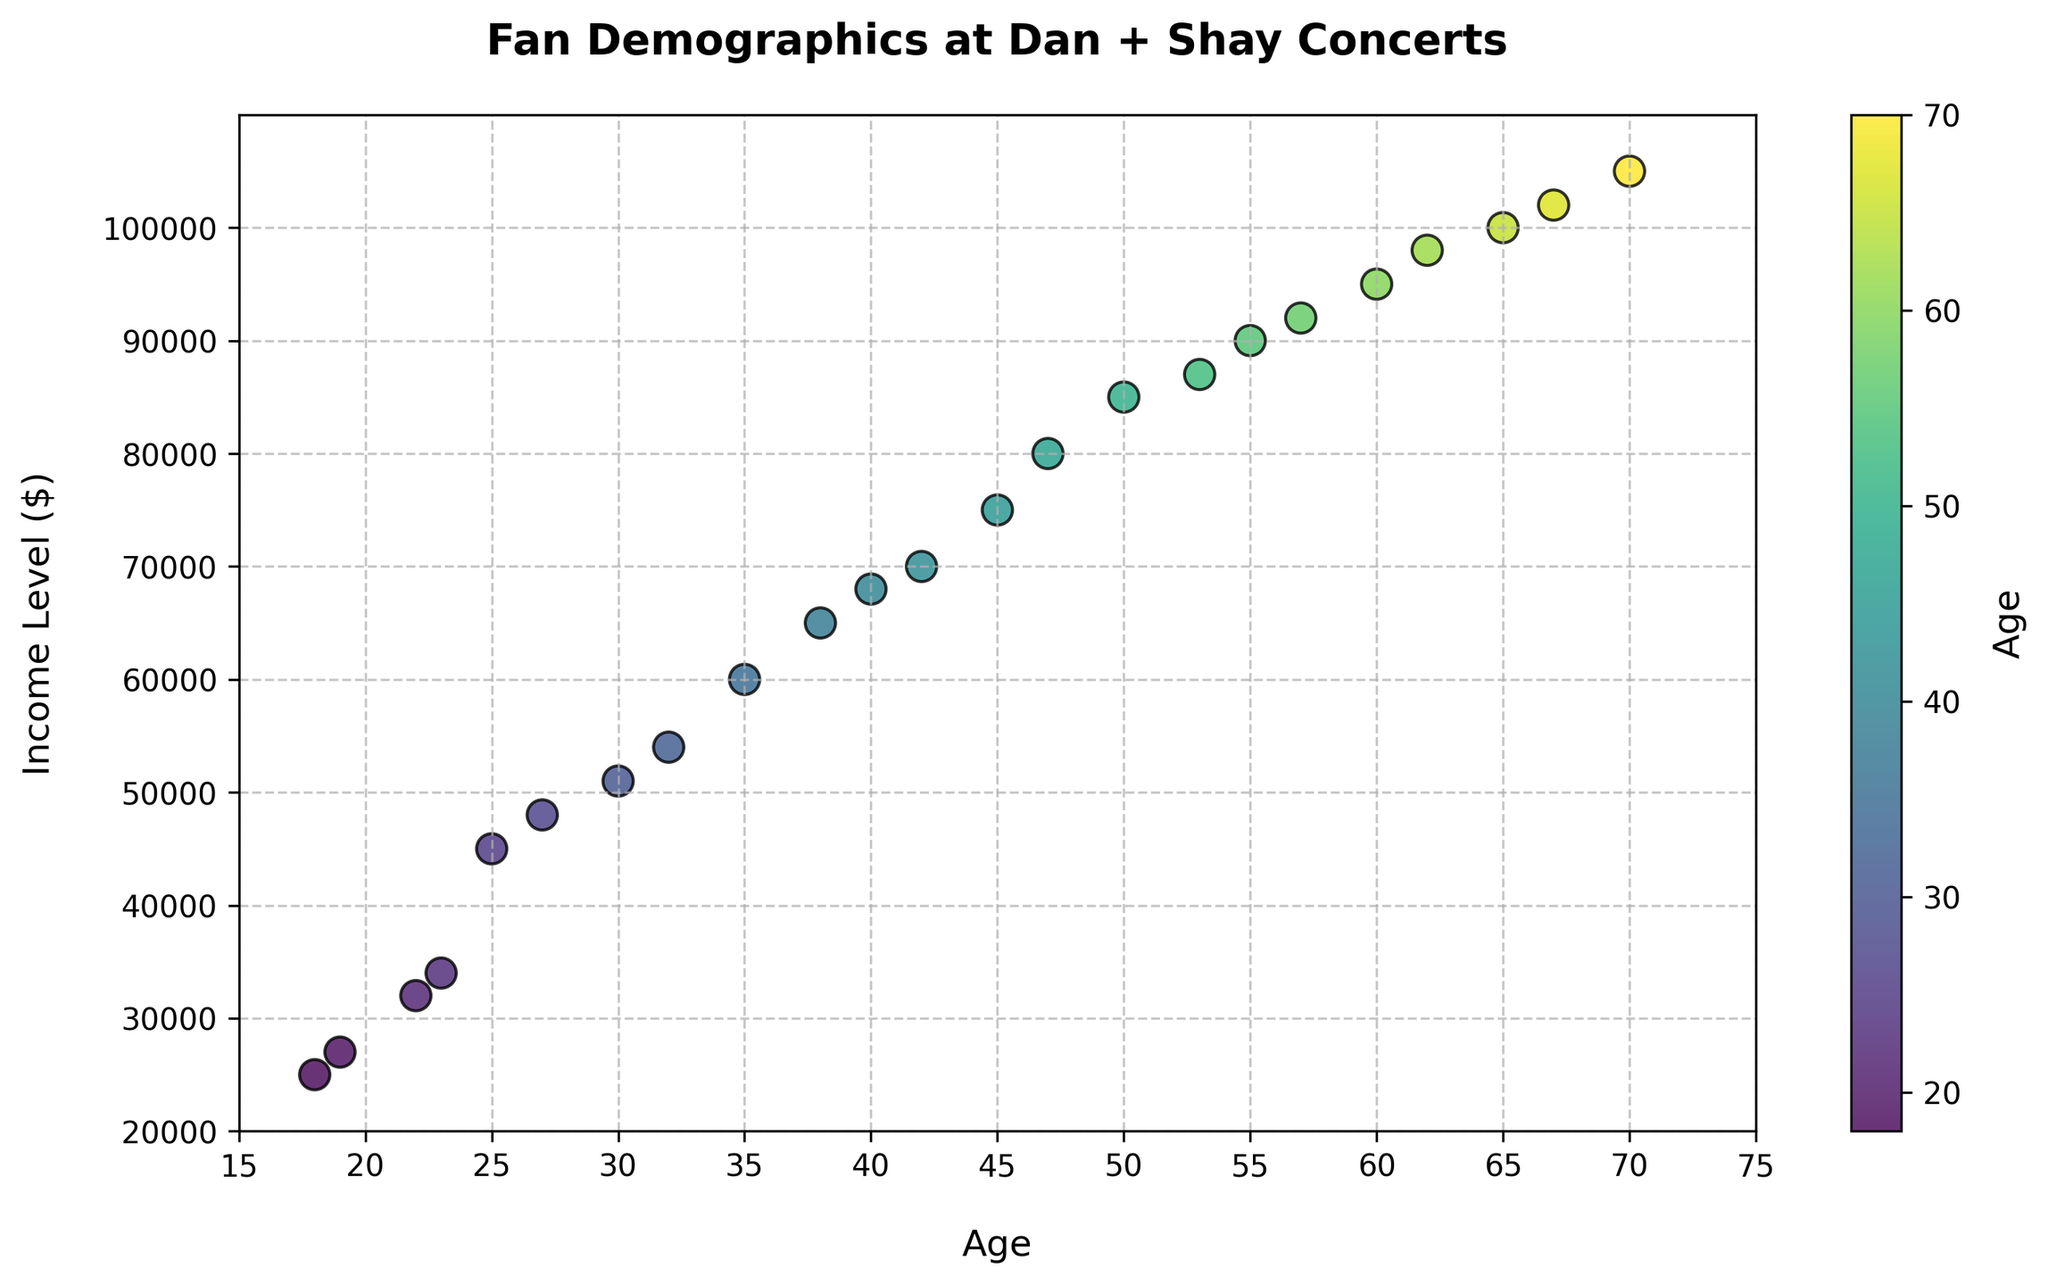What is the age range of the fans at the Dan + Shay concerts? The age range can be determined by identifying the minimum and maximum age values in the scatter plot. The minimum age is 18, and the maximum age is 70.
Answer: 18-70 What is the income level of the youngest fan? Identify the scatter plot point with the lowest age value. The corresponding income level for age 18 is $25,000.
Answer: $25,000 What is the median income level of fans aged 30 and above? Identify the income levels for fans aged 30 and older: $51,000, $54,000, $60,000, $65,000, $68,000, $70,000, $75,000, $80,000, $85,000, $87,000, $90,000, $92,000, $95,000, $98,000, $100,000, $102,000, $105,000. There are 17 values, so the median is the 9th value: $85,000.
Answer: $85,000 Which age group has an income level of $54,000? Locate the scatter plot point where the income level is $54,000. The corresponding age is 32.
Answer: 32 Is there a noticeable trend between age and income level? Observe the scatter plot for any patterns. The data points form a roughly upward trend, indicating that as age increases, income level tends to increase as well.
Answer: Yes, there is a positive trend How many fans have an income level above $50,000? Count the scatter plot points where the income level is greater than $50,000. There are 17 such points.
Answer: 17 What is the difference in income levels between the oldest and the youngest fan? Identify the income levels of the oldest fan (70 years old, $105,000) and the youngest fan (18 years old, $25,000). The difference is $105,000 - $25,000 = $80,000.
Answer: $80,000 Which fan age group shows the highest diversity in income levels? Observe how spread out the income levels are for different age groups. The 18-30 age range shows the highest diversity, with incomes ranging from $25,000 to $51,000.
Answer: 18-30 